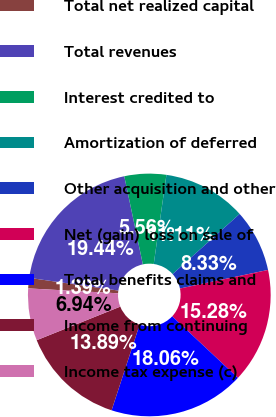<chart> <loc_0><loc_0><loc_500><loc_500><pie_chart><fcel>Total net realized capital<fcel>Total revenues<fcel>Interest credited to<fcel>Amortization of deferred<fcel>Other acquisition and other<fcel>Net (gain) loss on sale of<fcel>Total benefits claims and<fcel>Income from continuing<fcel>Income tax expense (c)<nl><fcel>1.39%<fcel>19.44%<fcel>5.56%<fcel>11.11%<fcel>8.33%<fcel>15.28%<fcel>18.06%<fcel>13.89%<fcel>6.94%<nl></chart> 